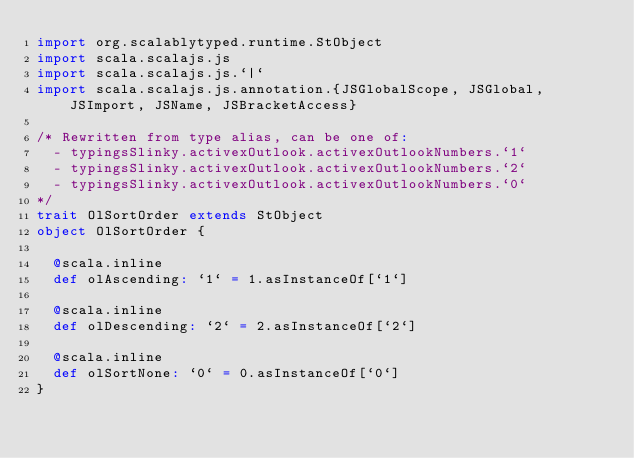Convert code to text. <code><loc_0><loc_0><loc_500><loc_500><_Scala_>import org.scalablytyped.runtime.StObject
import scala.scalajs.js
import scala.scalajs.js.`|`
import scala.scalajs.js.annotation.{JSGlobalScope, JSGlobal, JSImport, JSName, JSBracketAccess}

/* Rewritten from type alias, can be one of: 
  - typingsSlinky.activexOutlook.activexOutlookNumbers.`1`
  - typingsSlinky.activexOutlook.activexOutlookNumbers.`2`
  - typingsSlinky.activexOutlook.activexOutlookNumbers.`0`
*/
trait OlSortOrder extends StObject
object OlSortOrder {
  
  @scala.inline
  def olAscending: `1` = 1.asInstanceOf[`1`]
  
  @scala.inline
  def olDescending: `2` = 2.asInstanceOf[`2`]
  
  @scala.inline
  def olSortNone: `0` = 0.asInstanceOf[`0`]
}
</code> 